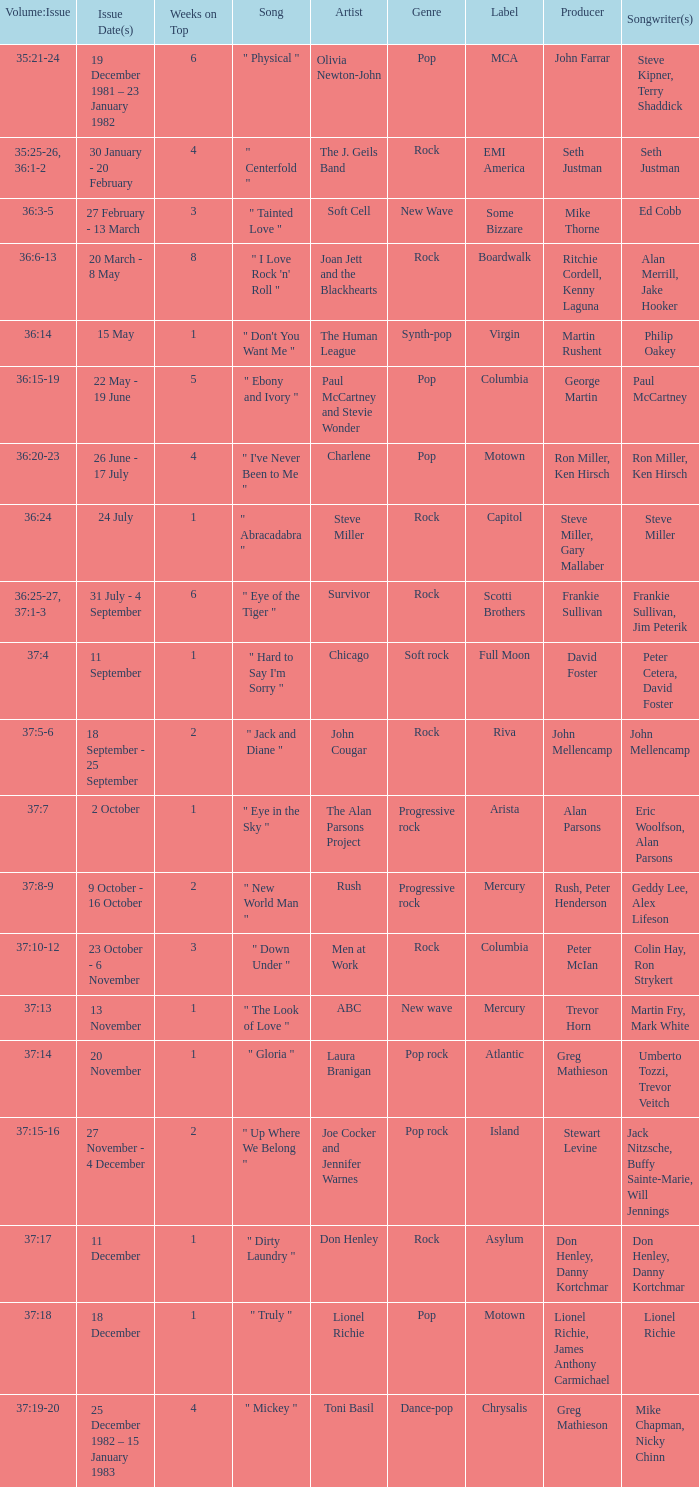Which Weeks on Top have an Issue Date(s) of 20 november? 1.0. 